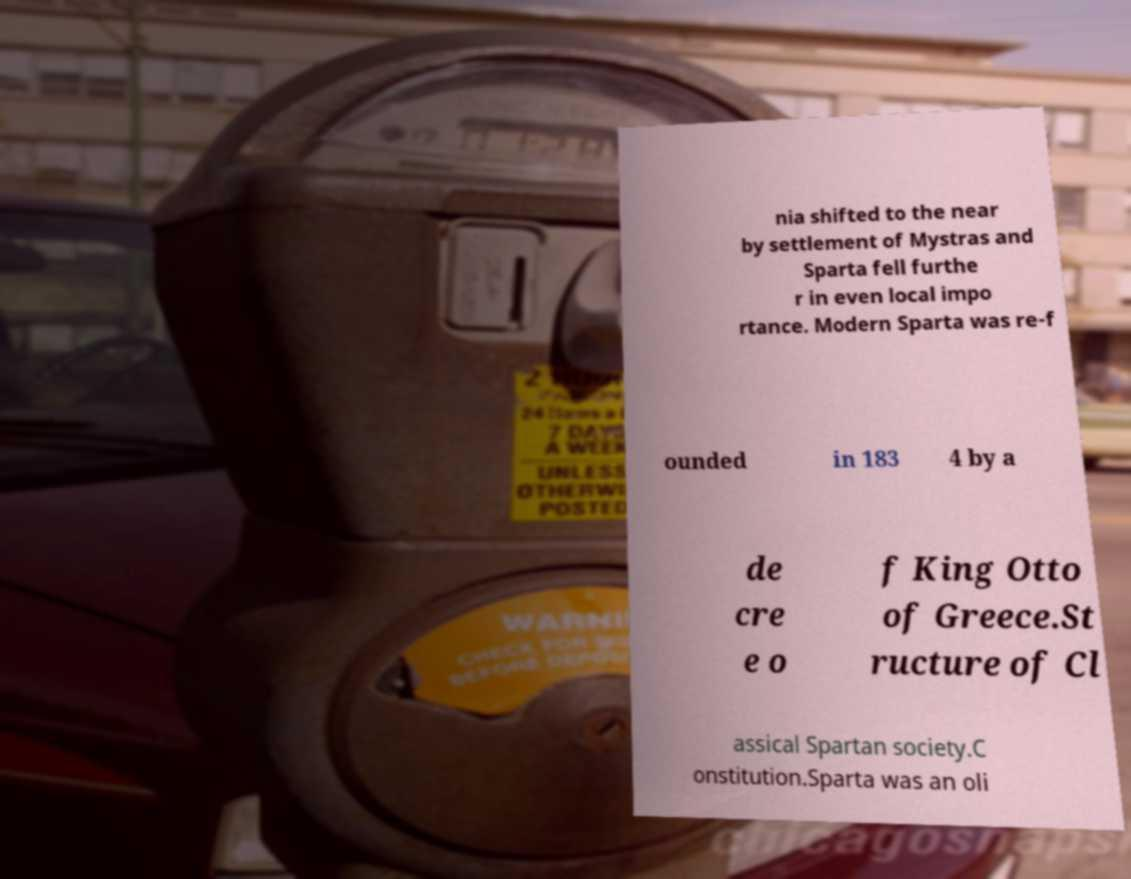Could you assist in decoding the text presented in this image and type it out clearly? nia shifted to the near by settlement of Mystras and Sparta fell furthe r in even local impo rtance. Modern Sparta was re-f ounded in 183 4 by a de cre e o f King Otto of Greece.St ructure of Cl assical Spartan society.C onstitution.Sparta was an oli 